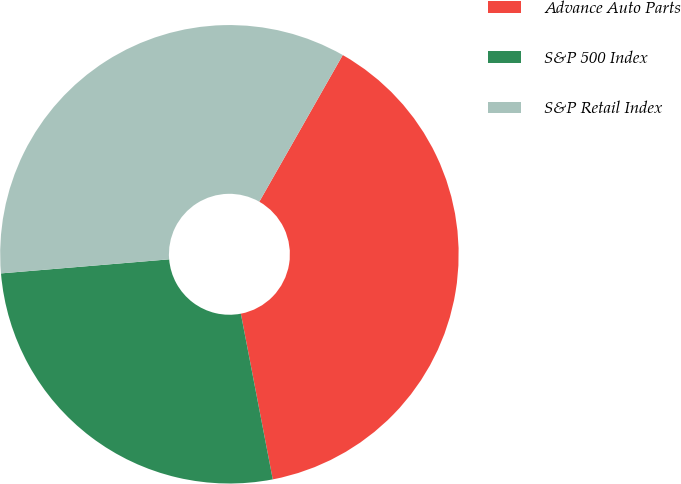<chart> <loc_0><loc_0><loc_500><loc_500><pie_chart><fcel>Advance Auto Parts<fcel>S&P 500 Index<fcel>S&P Retail Index<nl><fcel>38.74%<fcel>26.7%<fcel>34.56%<nl></chart> 